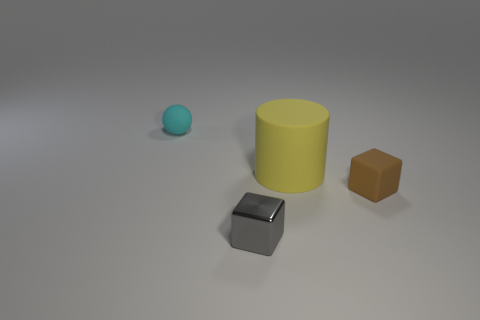What is the material of the gray thing?
Provide a succinct answer. Metal. Are any tiny brown rubber cylinders visible?
Offer a very short reply. No. Is the number of tiny brown rubber cubes on the right side of the small matte block the same as the number of large red rubber cubes?
Your answer should be compact. Yes. Are there any other things that have the same material as the gray block?
Your response must be concise. No. What number of large objects are yellow rubber objects or brown matte objects?
Provide a succinct answer. 1. Are the thing behind the large yellow object and the big cylinder made of the same material?
Offer a very short reply. Yes. There is a tiny thing behind the tiny cube that is right of the gray block; what is it made of?
Your answer should be very brief. Rubber. What number of other big matte objects are the same shape as the yellow matte thing?
Ensure brevity in your answer.  0. How big is the block that is to the left of the tiny rubber thing right of the matte ball to the left of the metallic thing?
Offer a very short reply. Small. How many brown things are large matte things or cubes?
Your answer should be very brief. 1. 